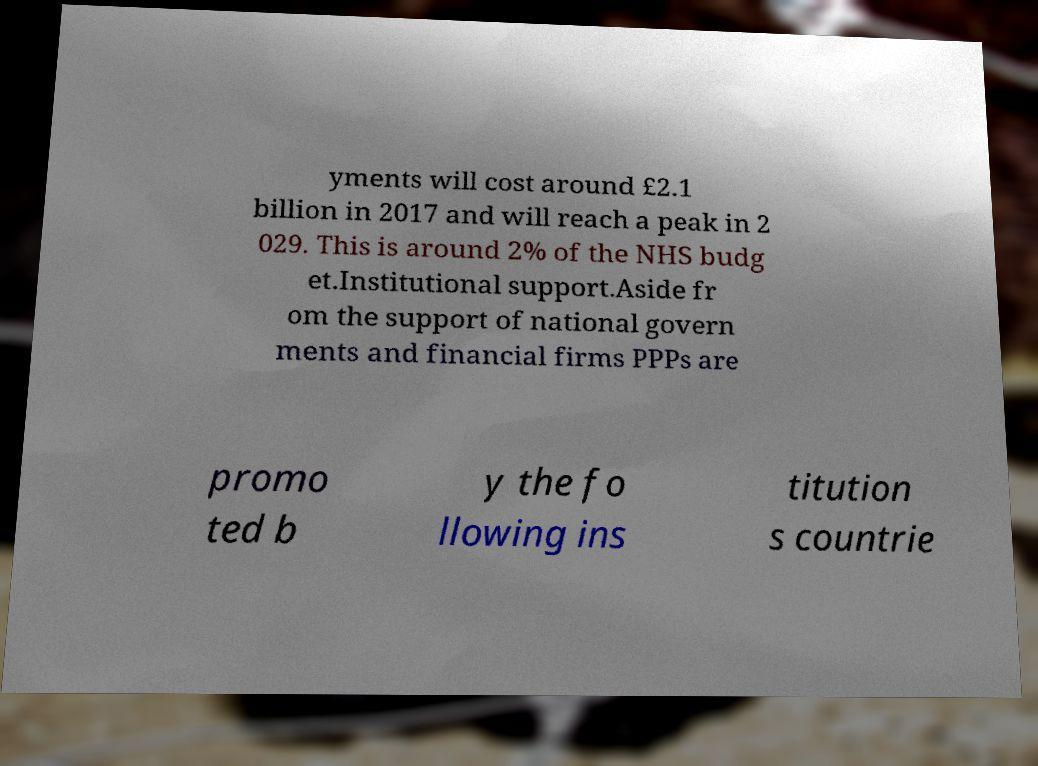I need the written content from this picture converted into text. Can you do that? yments will cost around £2.1 billion in 2017 and will reach a peak in 2 029. This is around 2% of the NHS budg et.Institutional support.Aside fr om the support of national govern ments and financial firms PPPs are promo ted b y the fo llowing ins titution s countrie 